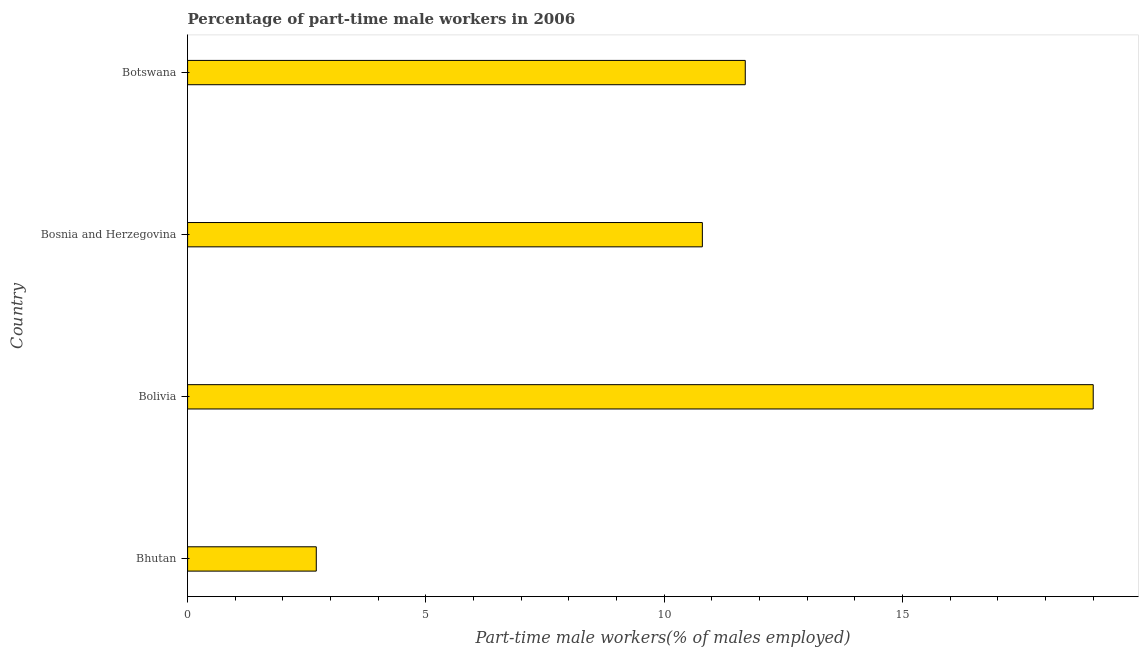Does the graph contain grids?
Keep it short and to the point. No. What is the title of the graph?
Your answer should be compact. Percentage of part-time male workers in 2006. What is the label or title of the X-axis?
Offer a terse response. Part-time male workers(% of males employed). What is the percentage of part-time male workers in Bolivia?
Offer a very short reply. 19. Across all countries, what is the minimum percentage of part-time male workers?
Keep it short and to the point. 2.7. In which country was the percentage of part-time male workers maximum?
Provide a succinct answer. Bolivia. In which country was the percentage of part-time male workers minimum?
Make the answer very short. Bhutan. What is the sum of the percentage of part-time male workers?
Ensure brevity in your answer.  44.2. What is the average percentage of part-time male workers per country?
Your response must be concise. 11.05. What is the median percentage of part-time male workers?
Make the answer very short. 11.25. In how many countries, is the percentage of part-time male workers greater than 3 %?
Offer a terse response. 3. What is the ratio of the percentage of part-time male workers in Bhutan to that in Bolivia?
Offer a terse response. 0.14. What is the difference between the highest and the second highest percentage of part-time male workers?
Offer a terse response. 7.3. Is the sum of the percentage of part-time male workers in Bosnia and Herzegovina and Botswana greater than the maximum percentage of part-time male workers across all countries?
Ensure brevity in your answer.  Yes. In how many countries, is the percentage of part-time male workers greater than the average percentage of part-time male workers taken over all countries?
Your answer should be compact. 2. How many bars are there?
Your answer should be very brief. 4. How many countries are there in the graph?
Make the answer very short. 4. What is the Part-time male workers(% of males employed) in Bhutan?
Ensure brevity in your answer.  2.7. What is the Part-time male workers(% of males employed) of Bolivia?
Your answer should be very brief. 19. What is the Part-time male workers(% of males employed) of Bosnia and Herzegovina?
Provide a succinct answer. 10.8. What is the Part-time male workers(% of males employed) of Botswana?
Give a very brief answer. 11.7. What is the difference between the Part-time male workers(% of males employed) in Bhutan and Bolivia?
Ensure brevity in your answer.  -16.3. What is the difference between the Part-time male workers(% of males employed) in Bhutan and Bosnia and Herzegovina?
Ensure brevity in your answer.  -8.1. What is the difference between the Part-time male workers(% of males employed) in Bhutan and Botswana?
Your answer should be compact. -9. What is the ratio of the Part-time male workers(% of males employed) in Bhutan to that in Bolivia?
Offer a very short reply. 0.14. What is the ratio of the Part-time male workers(% of males employed) in Bhutan to that in Bosnia and Herzegovina?
Offer a very short reply. 0.25. What is the ratio of the Part-time male workers(% of males employed) in Bhutan to that in Botswana?
Your answer should be very brief. 0.23. What is the ratio of the Part-time male workers(% of males employed) in Bolivia to that in Bosnia and Herzegovina?
Offer a very short reply. 1.76. What is the ratio of the Part-time male workers(% of males employed) in Bolivia to that in Botswana?
Your response must be concise. 1.62. What is the ratio of the Part-time male workers(% of males employed) in Bosnia and Herzegovina to that in Botswana?
Ensure brevity in your answer.  0.92. 